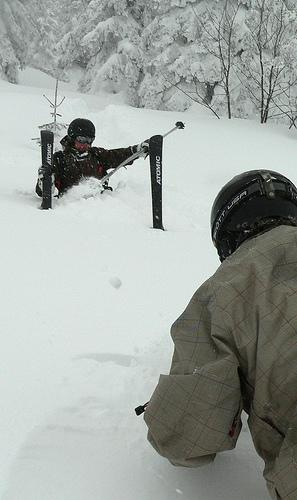Question: who is sitting?
Choices:
A. A runner.
B. A skier.
C. A coach.
D. A man.
Answer with the letter. Answer: B Question: what is directly behind the skier who has fallen?
Choices:
A. A small tree.
B. His skis.
C. Another skier.
D. A rock.
Answer with the letter. Answer: A Question: when was the picture taken?
Choices:
A. Morning.
B. Afternoon.
C. Midnight.
D. Daytime.
Answer with the letter. Answer: D 